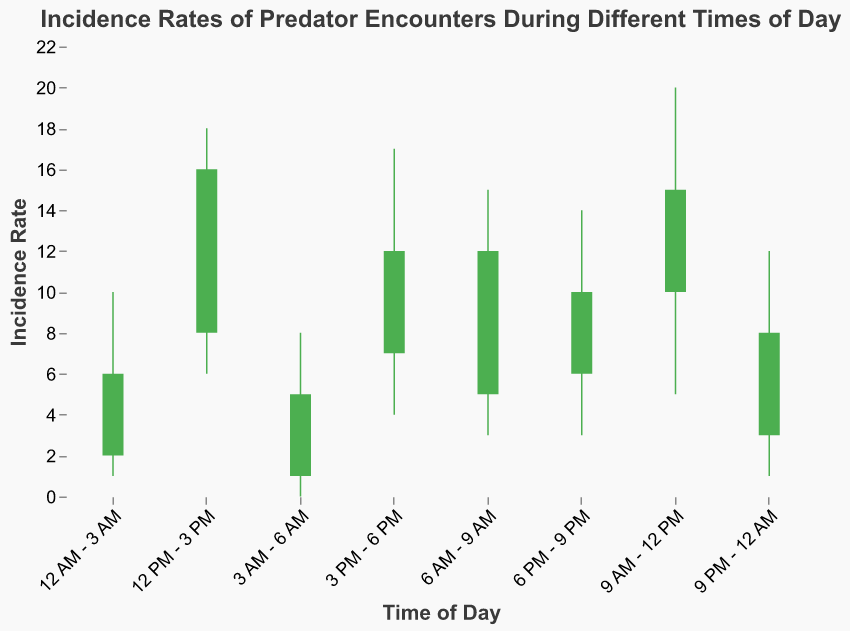What is the title of the plot? The title of the plot is directly shown at the top of the figure.
Answer: Incidence Rates of Predator Encounters During Different Times of Day Which time period has the highest incidence rate "High"? We need to look at the "High" values for each time period and identify the maximum one. The highest "High" value is 20 from the time period "9 AM - 12 PM".
Answer: 9 AM - 12 PM What are the open and close incidence rates for "6 PM - 9 PM"? Read the "Open" and "Close" values for "6 PM - 9 PM" from the figure data. "Open" is 6 and "Close" is 10.
Answer: Open: 6, Close: 10 During which time period was the lowest incidence rate "Low" recorded? Identify the minimum "Low" value across all time periods. The minimum "Low" value is 0 from "3 AM - 6 AM".
Answer: 3 AM - 6 AM Compare the open incidence rates of "6 AM - 9 AM" and "12 PM - 3 PM". Which one is higher? Look at the "Open" values for both periods. "6 AM - 9 AM" has "Open" 5 and "12 PM - 3 PM" has "Open" 8, so 8 is higher.
Answer: 12 PM - 3 PM What is the average "Close" incidence rate for time periods between 6 PM and 6 AM? Extract "Close" values for "6 PM - 9 PM", "9 PM - 12 AM", "12 AM - 3 AM", and "3 AM - 6 AM", then calculate the average: (10 + 8 + 6 + 5) / 4 = 7.25
Answer: 7.25 Which time period features the largest difference between "High" and "Low" incidence rates? Calculate the differences: for example "9 AM - 12 PM" has (20 - 5) = 15, etc. The largest difference is 15, during "9 AM - 12 PM".
Answer: 9 AM - 12 PM What colors represent an increase and a decrease in the candlestick bars? Analyze the color scheme in the plot, where bars are green if "Close" > "Open" and red if "Close" < "Open".
Answer: Green for increase, Red for decrease 